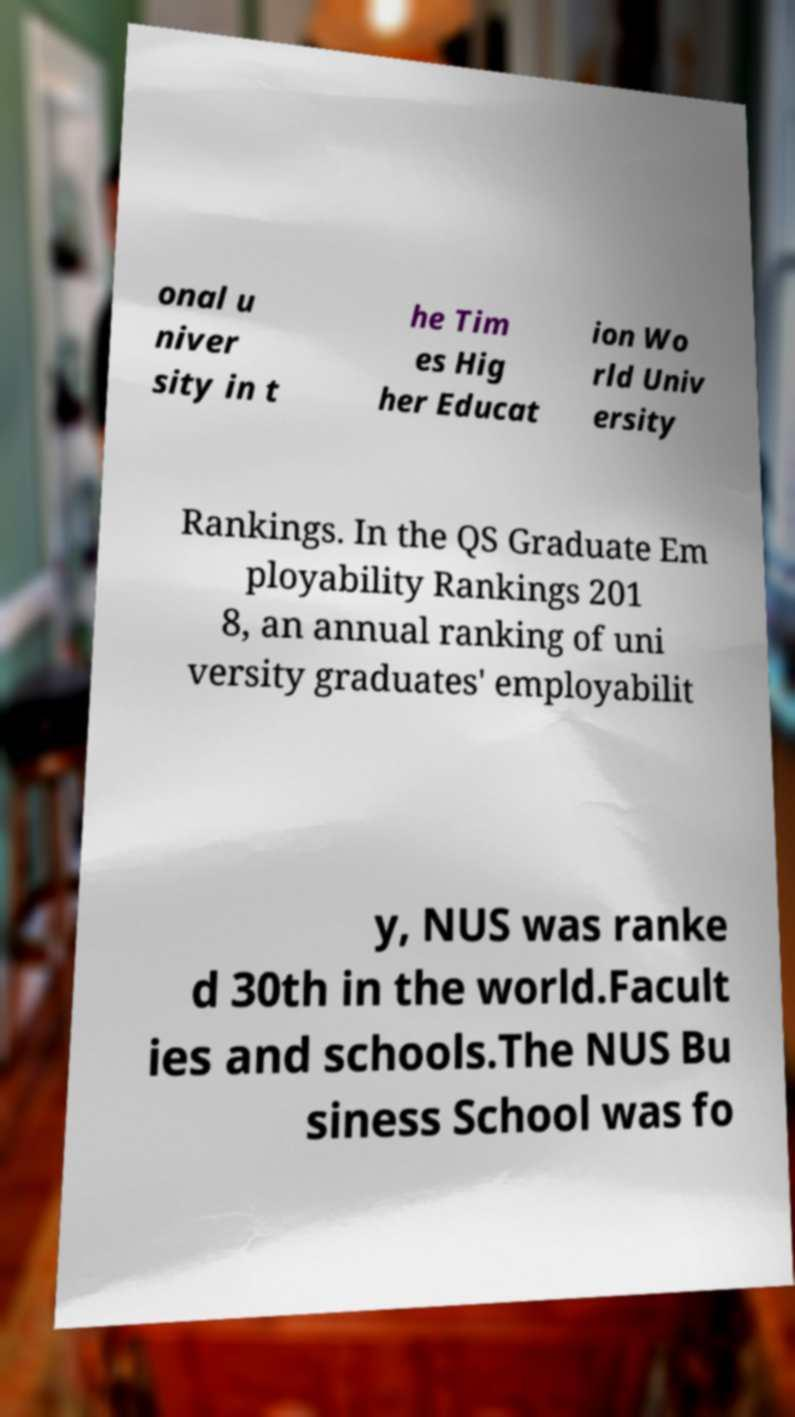There's text embedded in this image that I need extracted. Can you transcribe it verbatim? onal u niver sity in t he Tim es Hig her Educat ion Wo rld Univ ersity Rankings. In the QS Graduate Em ployability Rankings 201 8, an annual ranking of uni versity graduates' employabilit y, NUS was ranke d 30th in the world.Facult ies and schools.The NUS Bu siness School was fo 